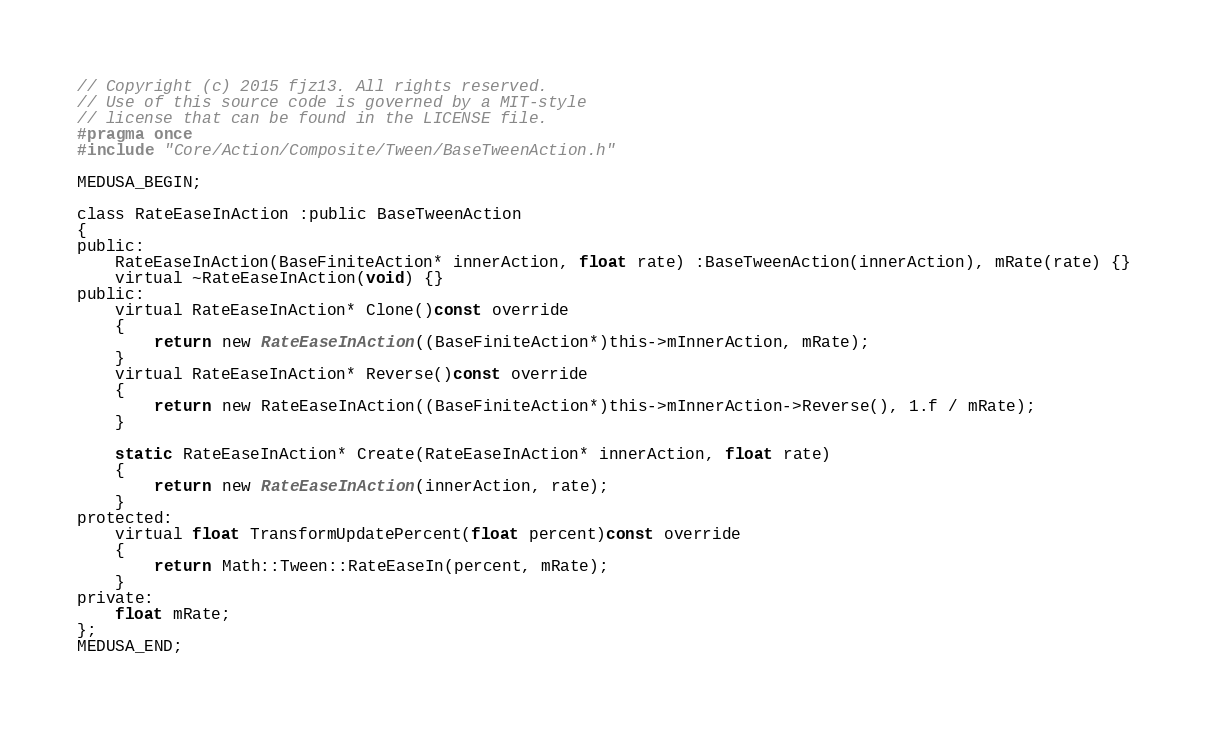Convert code to text. <code><loc_0><loc_0><loc_500><loc_500><_C_>// Copyright (c) 2015 fjz13. All rights reserved.
// Use of this source code is governed by a MIT-style
// license that can be found in the LICENSE file.
#pragma once
#include "Core/Action/Composite/Tween/BaseTweenAction.h"

MEDUSA_BEGIN;

class RateEaseInAction :public BaseTweenAction
{
public:
	RateEaseInAction(BaseFiniteAction* innerAction, float rate) :BaseTweenAction(innerAction), mRate(rate) {}
	virtual ~RateEaseInAction(void) {}
public:
	virtual RateEaseInAction* Clone()const override
	{
		return new RateEaseInAction((BaseFiniteAction*)this->mInnerAction, mRate);
	}
	virtual RateEaseInAction* Reverse()const override
	{
		return new RateEaseInAction((BaseFiniteAction*)this->mInnerAction->Reverse(), 1.f / mRate);
	}

	static RateEaseInAction* Create(RateEaseInAction* innerAction, float rate)
	{
		return new RateEaseInAction(innerAction, rate);
	}
protected:
	virtual float TransformUpdatePercent(float percent)const override
	{
		return Math::Tween::RateEaseIn(percent, mRate);
	}
private:
	float mRate;
};
MEDUSA_END;
</code> 